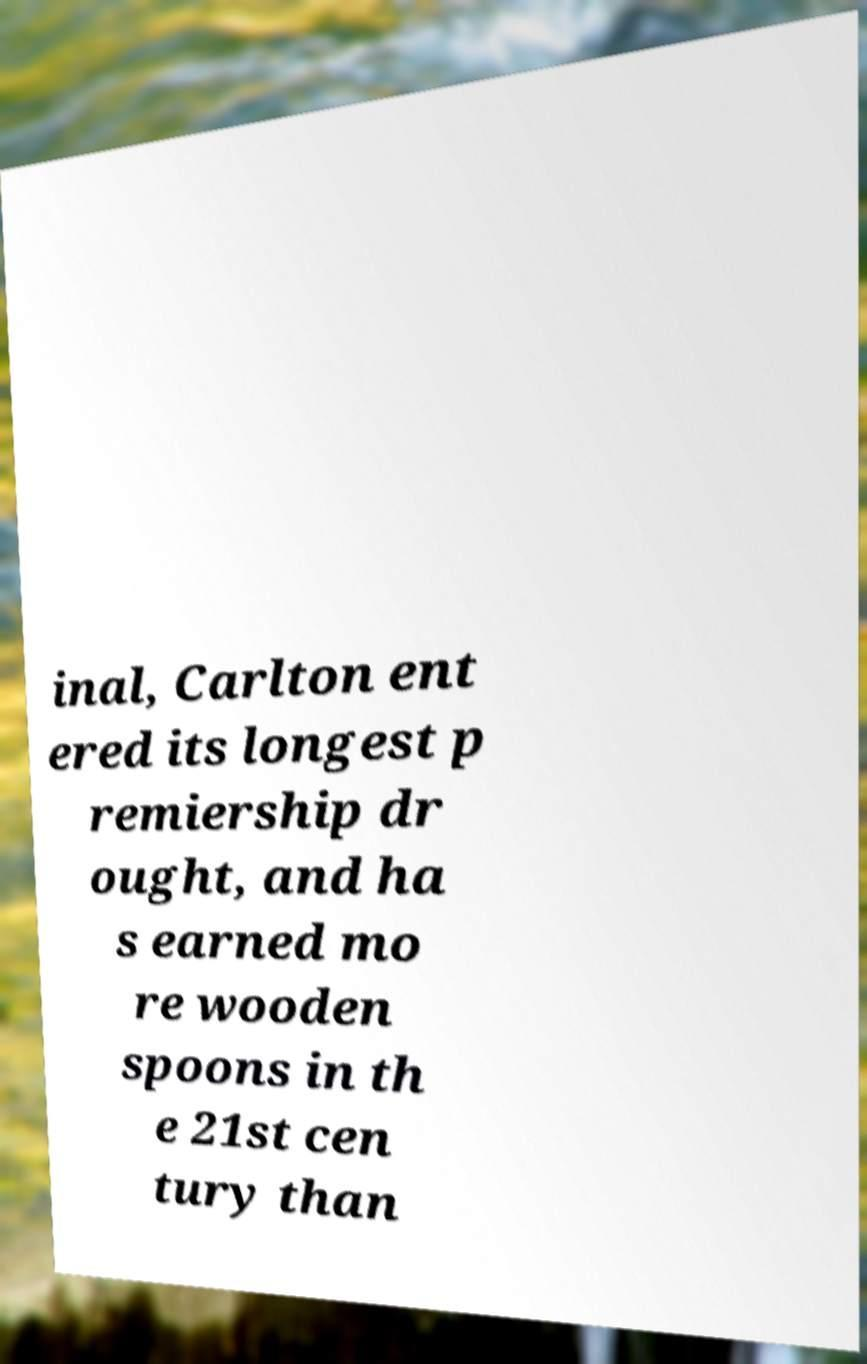I need the written content from this picture converted into text. Can you do that? inal, Carlton ent ered its longest p remiership dr ought, and ha s earned mo re wooden spoons in th e 21st cen tury than 